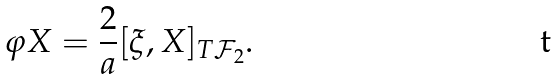<formula> <loc_0><loc_0><loc_500><loc_500>\varphi X = \frac { 2 } { a } [ \xi , X ] _ { T { \mathcal { F } } _ { 2 } } .</formula> 